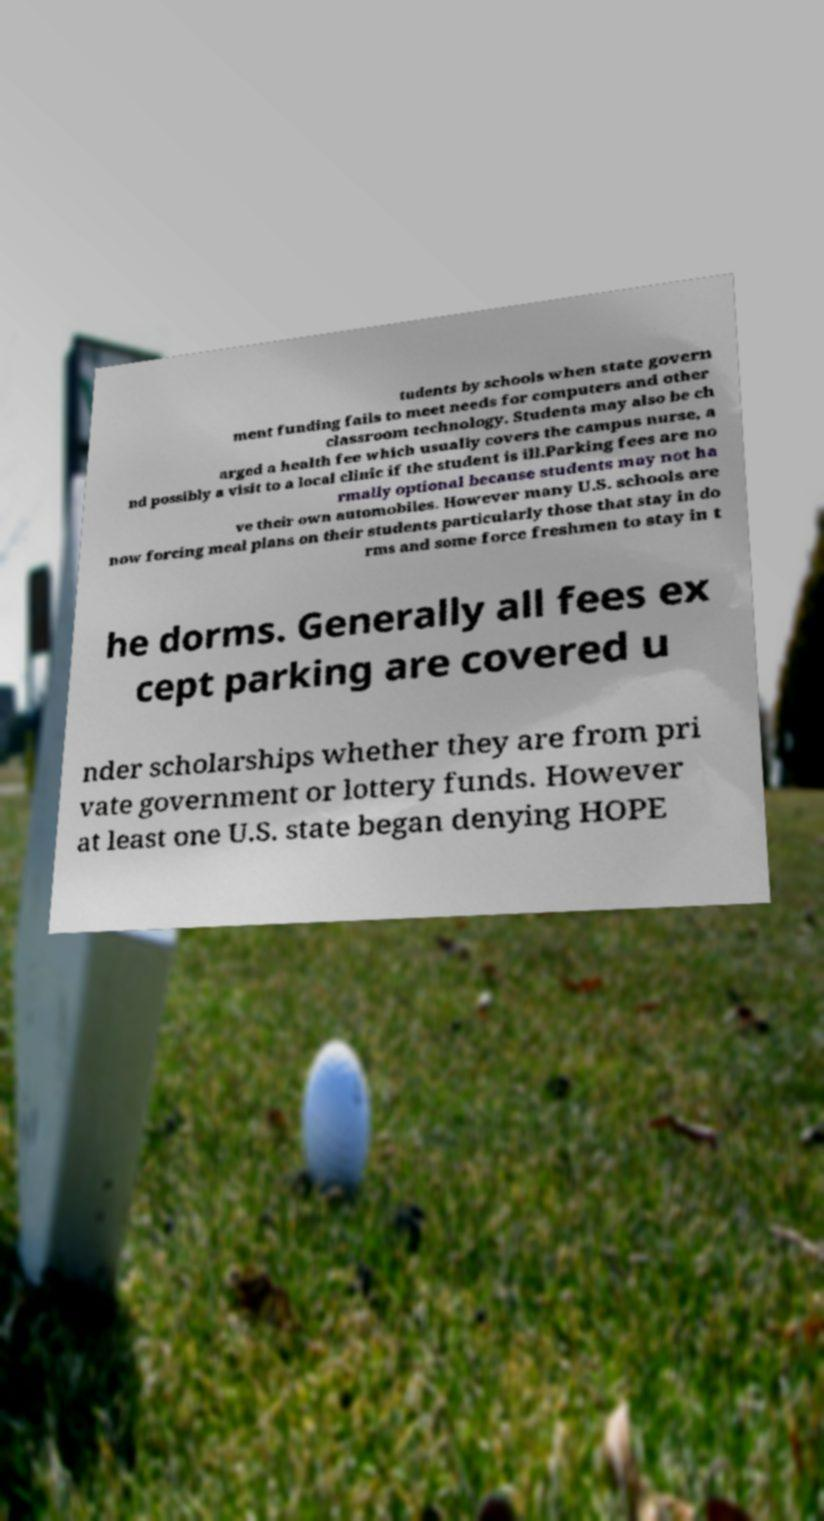Please identify and transcribe the text found in this image. tudents by schools when state govern ment funding fails to meet needs for computers and other classroom technology. Students may also be ch arged a health fee which usually covers the campus nurse, a nd possibly a visit to a local clinic if the student is ill.Parking fees are no rmally optional because students may not ha ve their own automobiles. However many U.S. schools are now forcing meal plans on their students particularly those that stay in do rms and some force freshmen to stay in t he dorms. Generally all fees ex cept parking are covered u nder scholarships whether they are from pri vate government or lottery funds. However at least one U.S. state began denying HOPE 